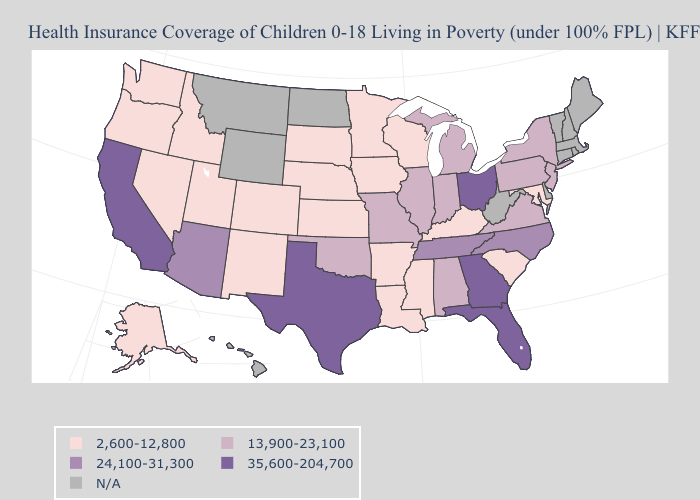Name the states that have a value in the range 35,600-204,700?
Answer briefly. California, Florida, Georgia, Ohio, Texas. Among the states that border Wisconsin , which have the lowest value?
Quick response, please. Iowa, Minnesota. Which states have the highest value in the USA?
Quick response, please. California, Florida, Georgia, Ohio, Texas. What is the lowest value in states that border New Jersey?
Give a very brief answer. 13,900-23,100. What is the lowest value in the South?
Give a very brief answer. 2,600-12,800. Name the states that have a value in the range 13,900-23,100?
Short answer required. Alabama, Illinois, Indiana, Michigan, Missouri, New Jersey, New York, Oklahoma, Pennsylvania, Virginia. Name the states that have a value in the range 24,100-31,300?
Short answer required. Arizona, North Carolina, Tennessee. Name the states that have a value in the range 35,600-204,700?
Write a very short answer. California, Florida, Georgia, Ohio, Texas. What is the highest value in states that border Washington?
Write a very short answer. 2,600-12,800. Does the first symbol in the legend represent the smallest category?
Quick response, please. Yes. What is the value of Wisconsin?
Keep it brief. 2,600-12,800. What is the lowest value in the USA?
Write a very short answer. 2,600-12,800. Among the states that border North Dakota , which have the lowest value?
Answer briefly. Minnesota, South Dakota. Does the first symbol in the legend represent the smallest category?
Quick response, please. Yes. 